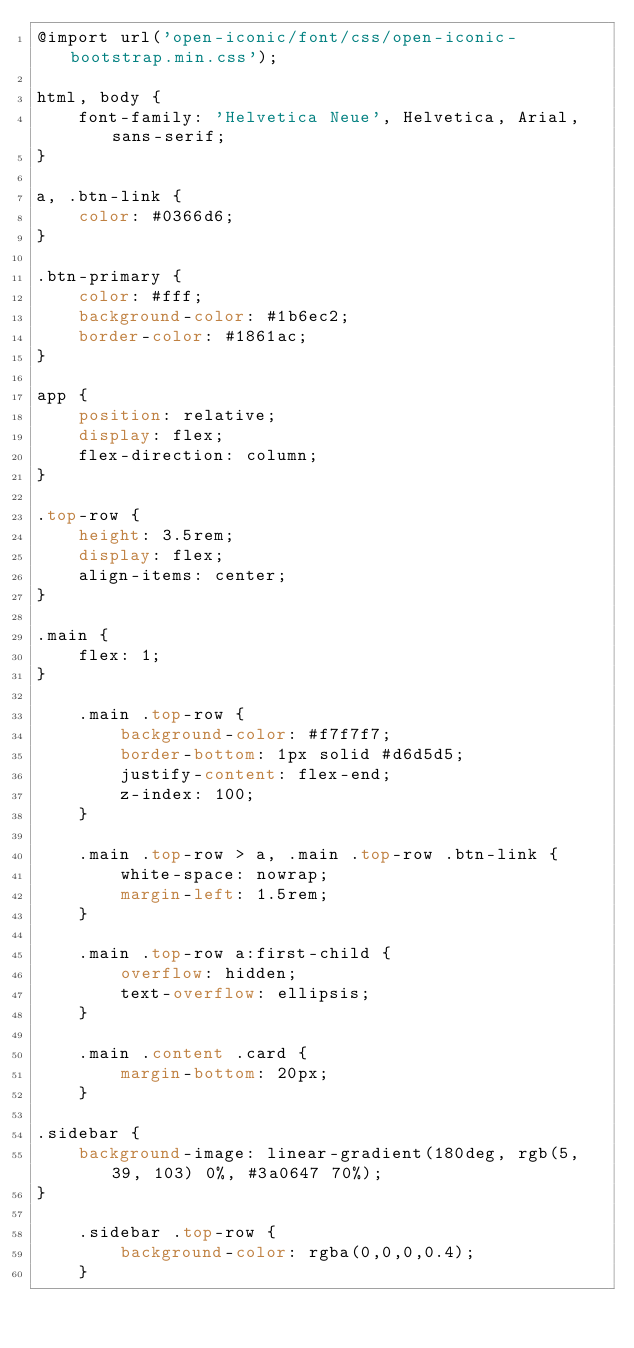<code> <loc_0><loc_0><loc_500><loc_500><_CSS_>@import url('open-iconic/font/css/open-iconic-bootstrap.min.css');

html, body {
    font-family: 'Helvetica Neue', Helvetica, Arial, sans-serif;
}

a, .btn-link {
    color: #0366d6;
}

.btn-primary {
    color: #fff;
    background-color: #1b6ec2;
    border-color: #1861ac;
}

app {
    position: relative;
    display: flex;
    flex-direction: column;
}

.top-row {
    height: 3.5rem;
    display: flex;
    align-items: center;
}

.main {
    flex: 1;
}

    .main .top-row {
        background-color: #f7f7f7;
        border-bottom: 1px solid #d6d5d5;
        justify-content: flex-end;
        z-index: 100;
    }

    .main .top-row > a, .main .top-row .btn-link {
        white-space: nowrap;
        margin-left: 1.5rem;
    }

    .main .top-row a:first-child {
        overflow: hidden;
        text-overflow: ellipsis;
    }

    .main .content .card {
        margin-bottom: 20px;
    }

.sidebar {
    background-image: linear-gradient(180deg, rgb(5, 39, 103) 0%, #3a0647 70%);
}

    .sidebar .top-row {
        background-color: rgba(0,0,0,0.4);
    }
</code> 